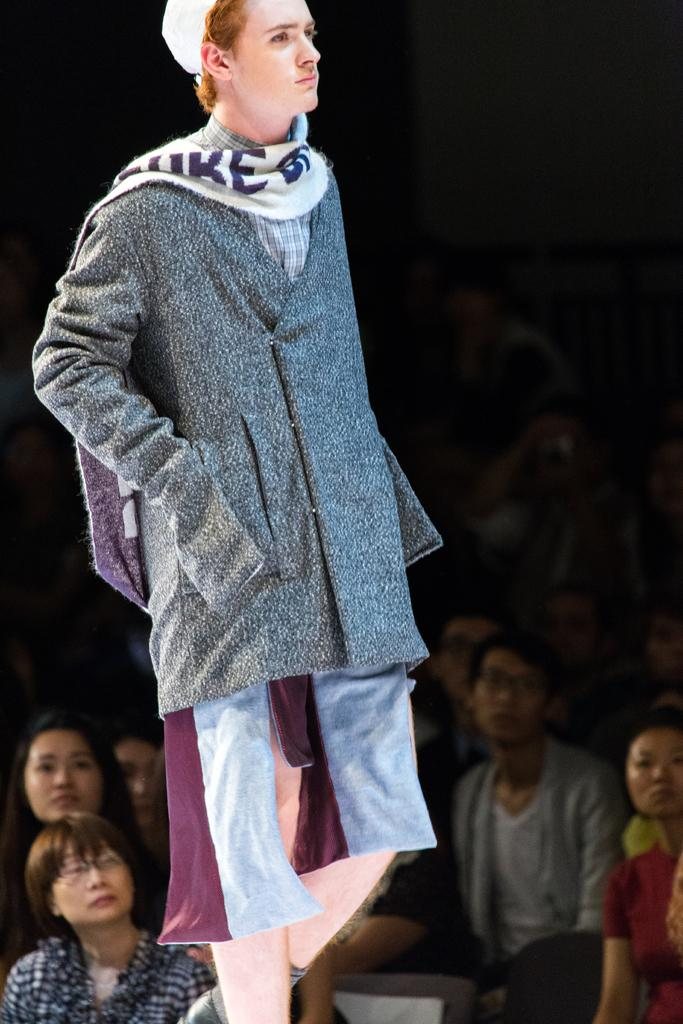What is the main subject of the image? There is a person standing in the center of the image. What is the person wearing? The person is wearing a different costume. Can you describe the people in the background of the image? There are people sitting in the background of the image. What type of glue is being used to attach the cable to the sock in the image? There is no glue, cable, or sock present in the image. 